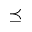<formula> <loc_0><loc_0><loc_500><loc_500>\preceq</formula> 